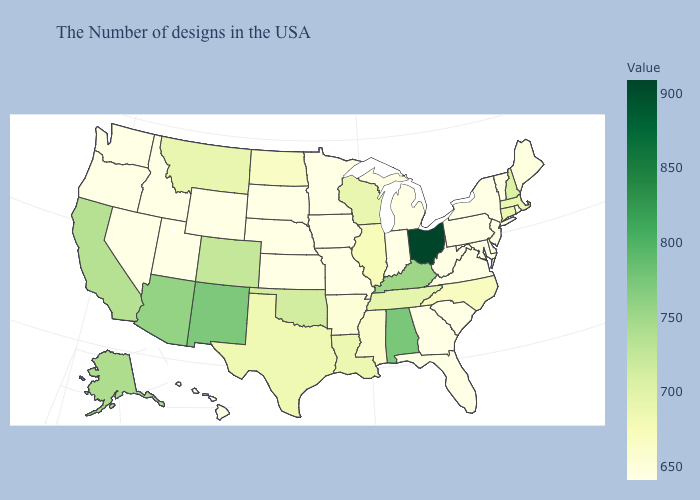Does Ohio have the highest value in the USA?
Concise answer only. Yes. Among the states that border Indiana , which have the lowest value?
Be succinct. Michigan. Which states have the lowest value in the South?
Write a very short answer. Delaware, Maryland, Virginia, South Carolina, West Virginia, Florida, Georgia. Does Illinois have a lower value than Utah?
Concise answer only. No. 